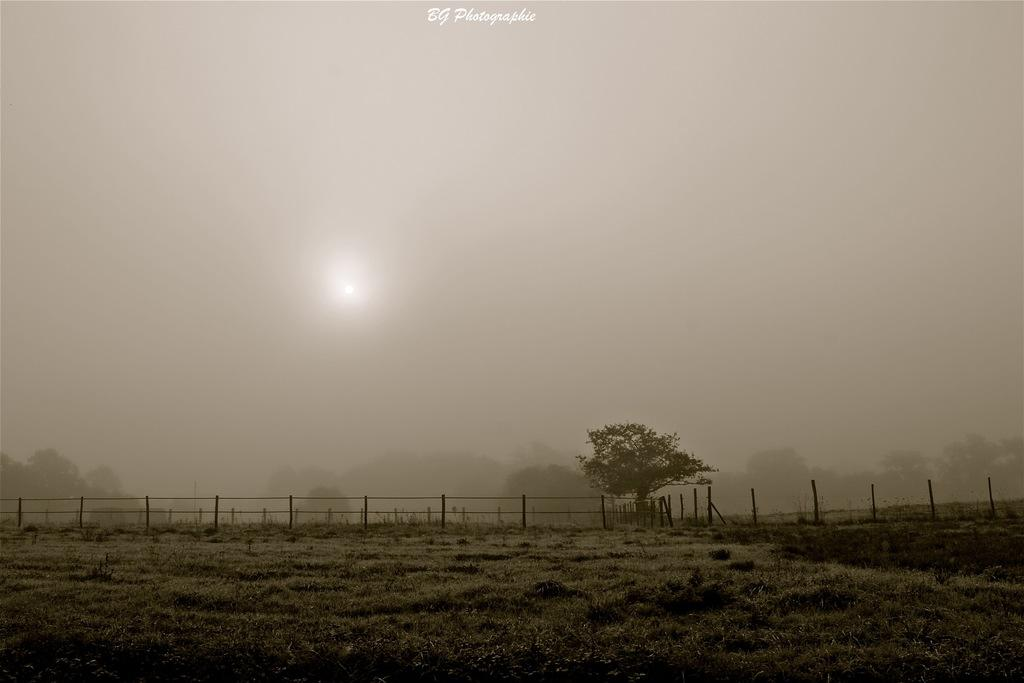What type of vegetation can be seen in the image? There are trees in the image. What is on the ground in the image? There is grass on the ground in the image. What atmospheric condition is present in the image? There is fog visible in the image. How is the image illuminated? The image appears to be illuminated by moonlight. What is written at the top of the image? There is text at the top of the image. Can you see any jellyfish swimming in the grass in the image? No, there are no jellyfish present in the image, and jellyfish do not swim in grass. What type of transportation is available at the airport depicted in the image? There is no airport depicted in the image, so it is not possible to answer that question. 